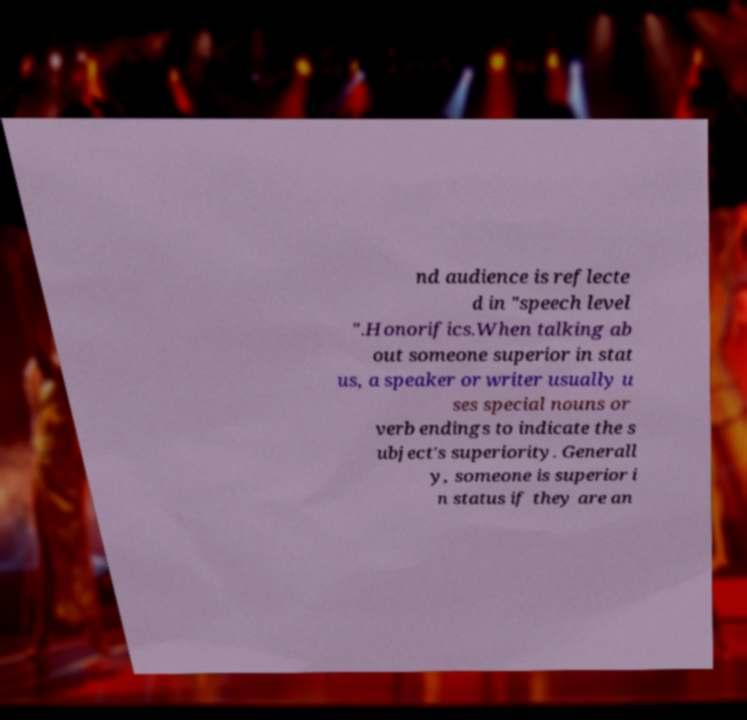Could you extract and type out the text from this image? nd audience is reflecte d in "speech level ".Honorifics.When talking ab out someone superior in stat us, a speaker or writer usually u ses special nouns or verb endings to indicate the s ubject's superiority. Generall y, someone is superior i n status if they are an 